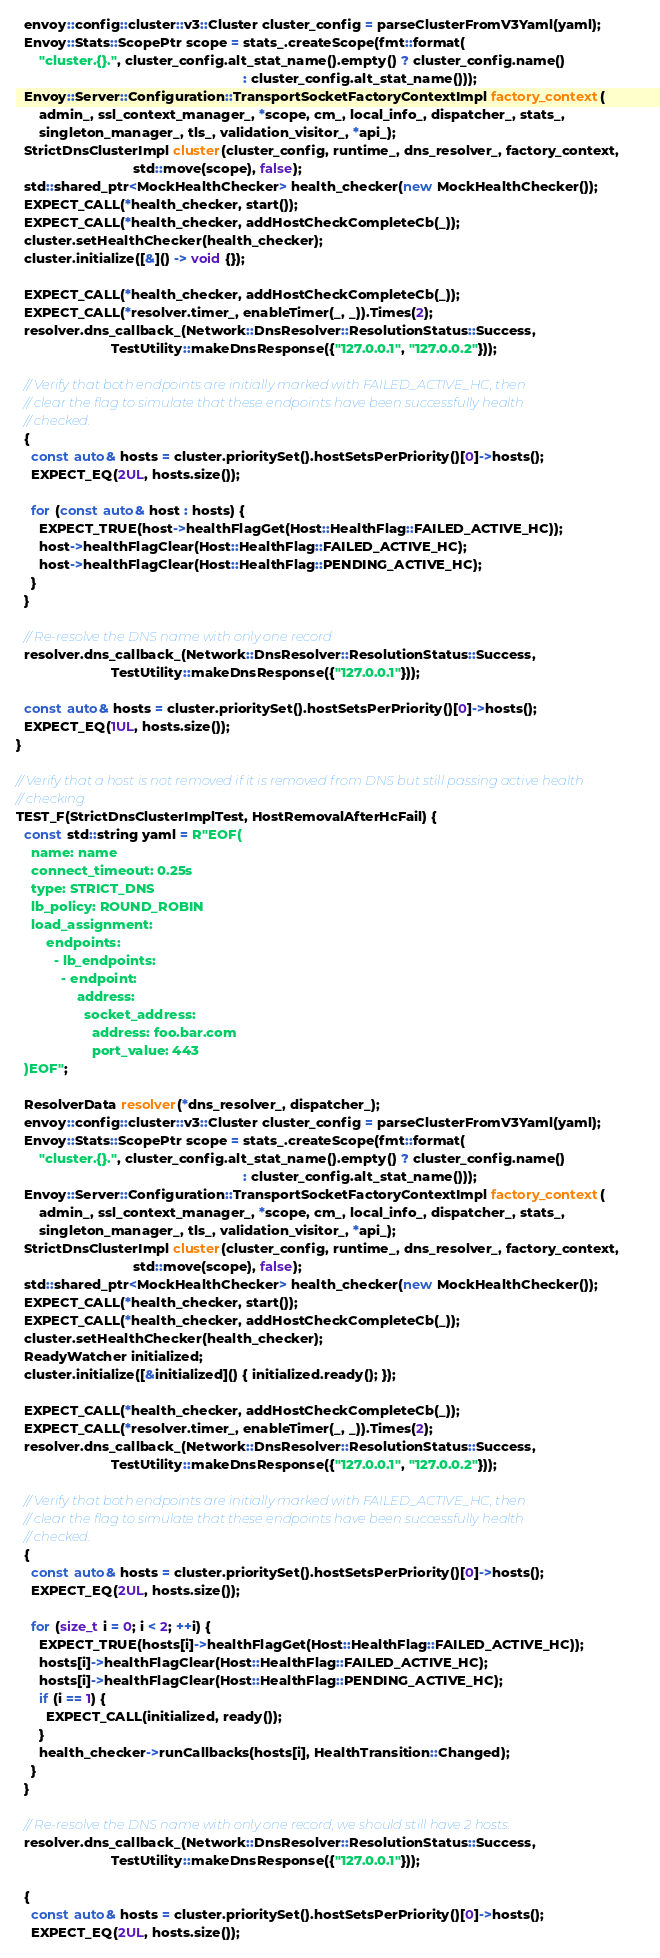<code> <loc_0><loc_0><loc_500><loc_500><_C++_>  envoy::config::cluster::v3::Cluster cluster_config = parseClusterFromV3Yaml(yaml);
  Envoy::Stats::ScopePtr scope = stats_.createScope(fmt::format(
      "cluster.{}.", cluster_config.alt_stat_name().empty() ? cluster_config.name()
                                                            : cluster_config.alt_stat_name()));
  Envoy::Server::Configuration::TransportSocketFactoryContextImpl factory_context(
      admin_, ssl_context_manager_, *scope, cm_, local_info_, dispatcher_, stats_,
      singleton_manager_, tls_, validation_visitor_, *api_);
  StrictDnsClusterImpl cluster(cluster_config, runtime_, dns_resolver_, factory_context,
                               std::move(scope), false);
  std::shared_ptr<MockHealthChecker> health_checker(new MockHealthChecker());
  EXPECT_CALL(*health_checker, start());
  EXPECT_CALL(*health_checker, addHostCheckCompleteCb(_));
  cluster.setHealthChecker(health_checker);
  cluster.initialize([&]() -> void {});

  EXPECT_CALL(*health_checker, addHostCheckCompleteCb(_));
  EXPECT_CALL(*resolver.timer_, enableTimer(_, _)).Times(2);
  resolver.dns_callback_(Network::DnsResolver::ResolutionStatus::Success,
                         TestUtility::makeDnsResponse({"127.0.0.1", "127.0.0.2"}));

  // Verify that both endpoints are initially marked with FAILED_ACTIVE_HC, then
  // clear the flag to simulate that these endpoints have been successfully health
  // checked.
  {
    const auto& hosts = cluster.prioritySet().hostSetsPerPriority()[0]->hosts();
    EXPECT_EQ(2UL, hosts.size());

    for (const auto& host : hosts) {
      EXPECT_TRUE(host->healthFlagGet(Host::HealthFlag::FAILED_ACTIVE_HC));
      host->healthFlagClear(Host::HealthFlag::FAILED_ACTIVE_HC);
      host->healthFlagClear(Host::HealthFlag::PENDING_ACTIVE_HC);
    }
  }

  // Re-resolve the DNS name with only one record
  resolver.dns_callback_(Network::DnsResolver::ResolutionStatus::Success,
                         TestUtility::makeDnsResponse({"127.0.0.1"}));

  const auto& hosts = cluster.prioritySet().hostSetsPerPriority()[0]->hosts();
  EXPECT_EQ(1UL, hosts.size());
}

// Verify that a host is not removed if it is removed from DNS but still passing active health
// checking.
TEST_F(StrictDnsClusterImplTest, HostRemovalAfterHcFail) {
  const std::string yaml = R"EOF(
    name: name
    connect_timeout: 0.25s
    type: STRICT_DNS
    lb_policy: ROUND_ROBIN
    load_assignment:
        endpoints:
          - lb_endpoints:
            - endpoint:
                address:
                  socket_address:
                    address: foo.bar.com
                    port_value: 443
  )EOF";

  ResolverData resolver(*dns_resolver_, dispatcher_);
  envoy::config::cluster::v3::Cluster cluster_config = parseClusterFromV3Yaml(yaml);
  Envoy::Stats::ScopePtr scope = stats_.createScope(fmt::format(
      "cluster.{}.", cluster_config.alt_stat_name().empty() ? cluster_config.name()
                                                            : cluster_config.alt_stat_name()));
  Envoy::Server::Configuration::TransportSocketFactoryContextImpl factory_context(
      admin_, ssl_context_manager_, *scope, cm_, local_info_, dispatcher_, stats_,
      singleton_manager_, tls_, validation_visitor_, *api_);
  StrictDnsClusterImpl cluster(cluster_config, runtime_, dns_resolver_, factory_context,
                               std::move(scope), false);
  std::shared_ptr<MockHealthChecker> health_checker(new MockHealthChecker());
  EXPECT_CALL(*health_checker, start());
  EXPECT_CALL(*health_checker, addHostCheckCompleteCb(_));
  cluster.setHealthChecker(health_checker);
  ReadyWatcher initialized;
  cluster.initialize([&initialized]() { initialized.ready(); });

  EXPECT_CALL(*health_checker, addHostCheckCompleteCb(_));
  EXPECT_CALL(*resolver.timer_, enableTimer(_, _)).Times(2);
  resolver.dns_callback_(Network::DnsResolver::ResolutionStatus::Success,
                         TestUtility::makeDnsResponse({"127.0.0.1", "127.0.0.2"}));

  // Verify that both endpoints are initially marked with FAILED_ACTIVE_HC, then
  // clear the flag to simulate that these endpoints have been successfully health
  // checked.
  {
    const auto& hosts = cluster.prioritySet().hostSetsPerPriority()[0]->hosts();
    EXPECT_EQ(2UL, hosts.size());

    for (size_t i = 0; i < 2; ++i) {
      EXPECT_TRUE(hosts[i]->healthFlagGet(Host::HealthFlag::FAILED_ACTIVE_HC));
      hosts[i]->healthFlagClear(Host::HealthFlag::FAILED_ACTIVE_HC);
      hosts[i]->healthFlagClear(Host::HealthFlag::PENDING_ACTIVE_HC);
      if (i == 1) {
        EXPECT_CALL(initialized, ready());
      }
      health_checker->runCallbacks(hosts[i], HealthTransition::Changed);
    }
  }

  // Re-resolve the DNS name with only one record, we should still have 2 hosts.
  resolver.dns_callback_(Network::DnsResolver::ResolutionStatus::Success,
                         TestUtility::makeDnsResponse({"127.0.0.1"}));

  {
    const auto& hosts = cluster.prioritySet().hostSetsPerPriority()[0]->hosts();
    EXPECT_EQ(2UL, hosts.size());</code> 